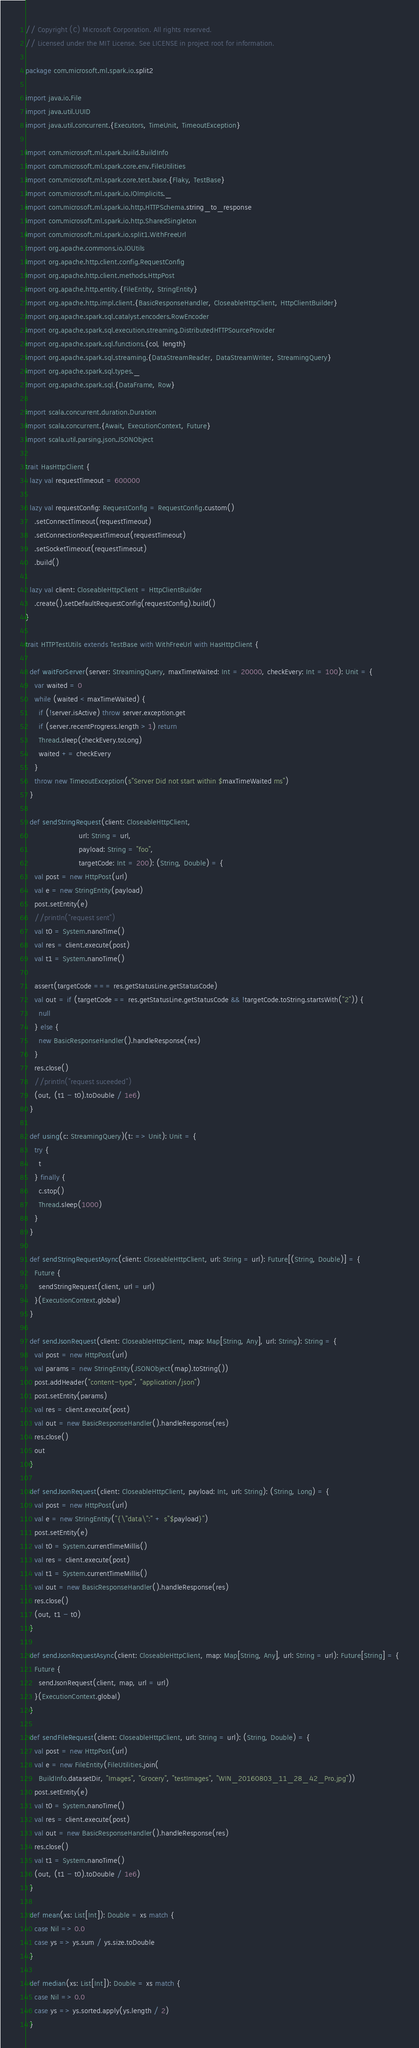<code> <loc_0><loc_0><loc_500><loc_500><_Scala_>// Copyright (C) Microsoft Corporation. All rights reserved.
// Licensed under the MIT License. See LICENSE in project root for information.

package com.microsoft.ml.spark.io.split2

import java.io.File
import java.util.UUID
import java.util.concurrent.{Executors, TimeUnit, TimeoutException}

import com.microsoft.ml.spark.build.BuildInfo
import com.microsoft.ml.spark.core.env.FileUtilities
import com.microsoft.ml.spark.core.test.base.{Flaky, TestBase}
import com.microsoft.ml.spark.io.IOImplicits._
import com.microsoft.ml.spark.io.http.HTTPSchema.string_to_response
import com.microsoft.ml.spark.io.http.SharedSingleton
import com.microsoft.ml.spark.io.split1.WithFreeUrl
import org.apache.commons.io.IOUtils
import org.apache.http.client.config.RequestConfig
import org.apache.http.client.methods.HttpPost
import org.apache.http.entity.{FileEntity, StringEntity}
import org.apache.http.impl.client.{BasicResponseHandler, CloseableHttpClient, HttpClientBuilder}
import org.apache.spark.sql.catalyst.encoders.RowEncoder
import org.apache.spark.sql.execution.streaming.DistributedHTTPSourceProvider
import org.apache.spark.sql.functions.{col, length}
import org.apache.spark.sql.streaming.{DataStreamReader, DataStreamWriter, StreamingQuery}
import org.apache.spark.sql.types._
import org.apache.spark.sql.{DataFrame, Row}

import scala.concurrent.duration.Duration
import scala.concurrent.{Await, ExecutionContext, Future}
import scala.util.parsing.json.JSONObject

trait HasHttpClient {
  lazy val requestTimeout = 600000

  lazy val requestConfig: RequestConfig = RequestConfig.custom()
    .setConnectTimeout(requestTimeout)
    .setConnectionRequestTimeout(requestTimeout)
    .setSocketTimeout(requestTimeout)
    .build()

  lazy val client: CloseableHttpClient = HttpClientBuilder
    .create().setDefaultRequestConfig(requestConfig).build()
}

trait HTTPTestUtils extends TestBase with WithFreeUrl with HasHttpClient {

  def waitForServer(server: StreamingQuery, maxTimeWaited: Int = 20000, checkEvery: Int = 100): Unit = {
    var waited = 0
    while (waited < maxTimeWaited) {
      if (!server.isActive) throw server.exception.get
      if (server.recentProgress.length > 1) return
      Thread.sleep(checkEvery.toLong)
      waited += checkEvery
    }
    throw new TimeoutException(s"Server Did not start within $maxTimeWaited ms")
  }

  def sendStringRequest(client: CloseableHttpClient,
                        url: String = url,
                        payload: String = "foo",
                        targetCode: Int = 200): (String, Double) = {
    val post = new HttpPost(url)
    val e = new StringEntity(payload)
    post.setEntity(e)
    //println("request sent")
    val t0 = System.nanoTime()
    val res = client.execute(post)
    val t1 = System.nanoTime()

    assert(targetCode === res.getStatusLine.getStatusCode)
    val out = if (targetCode == res.getStatusLine.getStatusCode && !targetCode.toString.startsWith("2")) {
      null
    } else {
      new BasicResponseHandler().handleResponse(res)
    }
    res.close()
    //println("request suceeded")
    (out, (t1 - t0).toDouble / 1e6)
  }

  def using(c: StreamingQuery)(t: => Unit): Unit = {
    try {
      t
    } finally {
      c.stop()
      Thread.sleep(1000)
    }
  }

  def sendStringRequestAsync(client: CloseableHttpClient, url: String = url): Future[(String, Double)] = {
    Future {
      sendStringRequest(client, url = url)
    }(ExecutionContext.global)
  }

  def sendJsonRequest(client: CloseableHttpClient, map: Map[String, Any], url: String): String = {
    val post = new HttpPost(url)
    val params = new StringEntity(JSONObject(map).toString())
    post.addHeader("content-type", "application/json")
    post.setEntity(params)
    val res = client.execute(post)
    val out = new BasicResponseHandler().handleResponse(res)
    res.close()
    out
  }

  def sendJsonRequest(client: CloseableHttpClient, payload: Int, url: String): (String, Long) = {
    val post = new HttpPost(url)
    val e = new StringEntity("{\"data\":" + s"$payload}")
    post.setEntity(e)
    val t0 = System.currentTimeMillis()
    val res = client.execute(post)
    val t1 = System.currentTimeMillis()
    val out = new BasicResponseHandler().handleResponse(res)
    res.close()
    (out, t1 - t0)
  }

  def sendJsonRequestAsync(client: CloseableHttpClient, map: Map[String, Any], url: String = url): Future[String] = {
    Future {
      sendJsonRequest(client, map, url = url)
    }(ExecutionContext.global)
  }

  def sendFileRequest(client: CloseableHttpClient, url: String = url): (String, Double) = {
    val post = new HttpPost(url)
    val e = new FileEntity(FileUtilities.join(
      BuildInfo.datasetDir, "Images", "Grocery", "testImages", "WIN_20160803_11_28_42_Pro.jpg"))
    post.setEntity(e)
    val t0 = System.nanoTime()
    val res = client.execute(post)
    val out = new BasicResponseHandler().handleResponse(res)
    res.close()
    val t1 = System.nanoTime()
    (out, (t1 - t0).toDouble / 1e6)
  }

  def mean(xs: List[Int]): Double = xs match {
    case Nil => 0.0
    case ys => ys.sum / ys.size.toDouble
  }

  def median(xs: List[Int]): Double = xs match {
    case Nil => 0.0
    case ys => ys.sorted.apply(ys.length / 2)
  }
</code> 